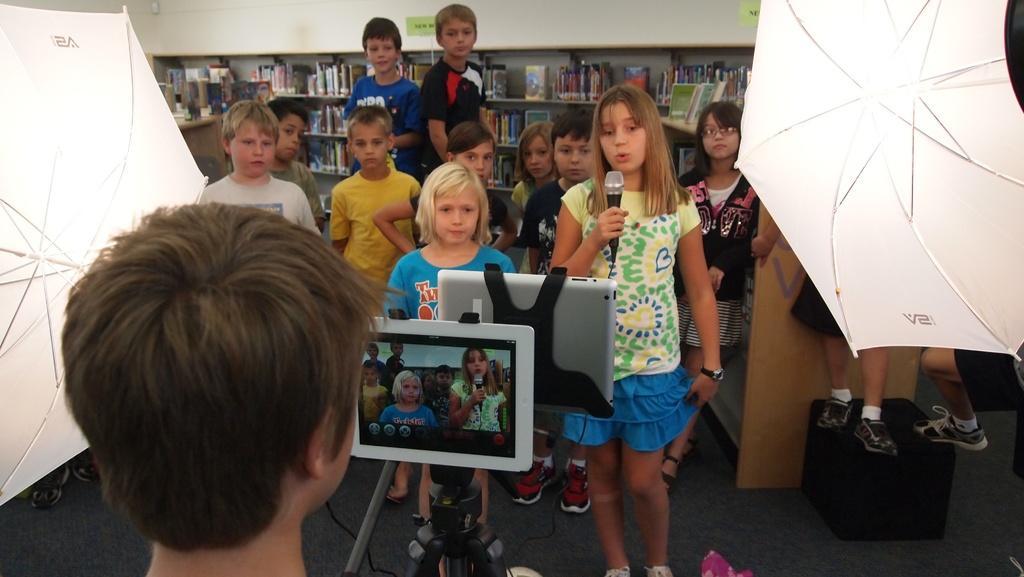Describe this image in one or two sentences. In this image in the center there are some children standing one girl is holding a mike and talking. In the foreground there is one boy and there is a stand and i pads, on the right side and left side there are umbrellas and in the background there are book racks. In the book racks there are some books, at the bottom there is floor and on the right side there is one box. On the box there are two children who are standing. 